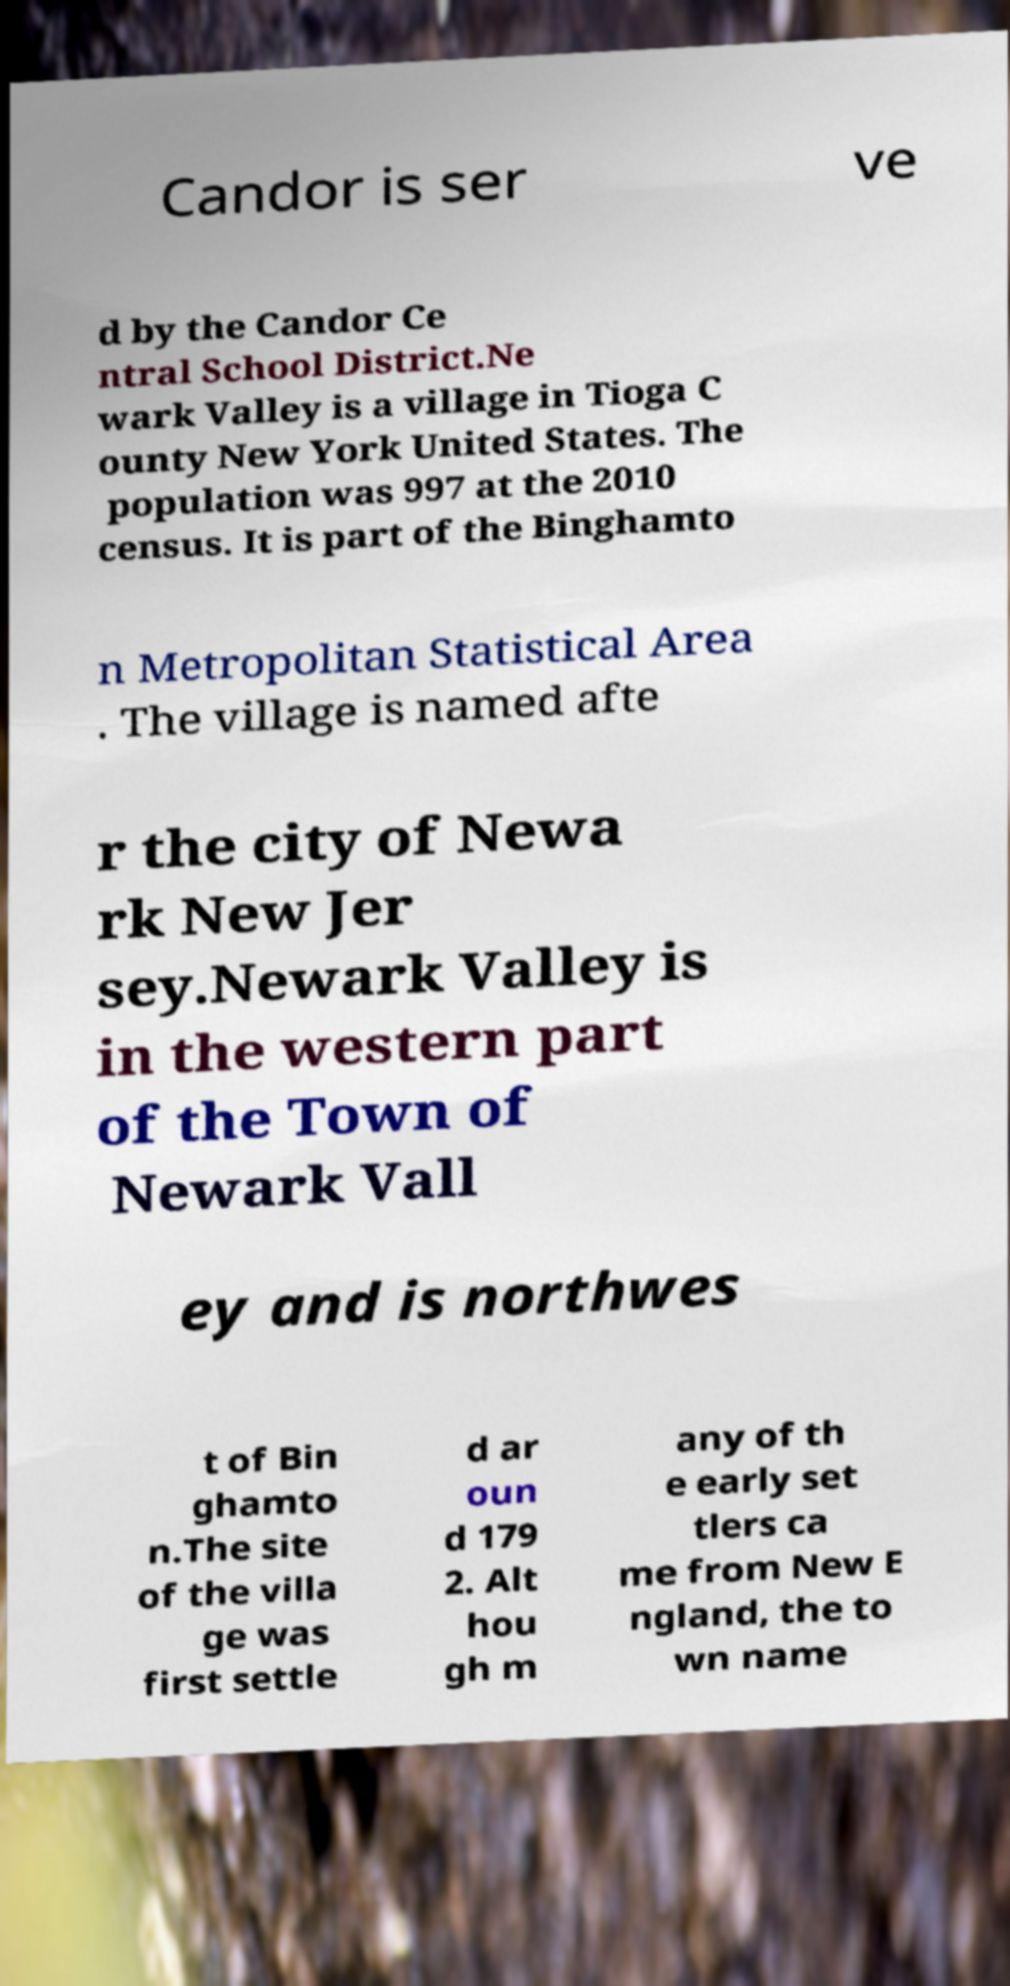There's text embedded in this image that I need extracted. Can you transcribe it verbatim? Candor is ser ve d by the Candor Ce ntral School District.Ne wark Valley is a village in Tioga C ounty New York United States. The population was 997 at the 2010 census. It is part of the Binghamto n Metropolitan Statistical Area . The village is named afte r the city of Newa rk New Jer sey.Newark Valley is in the western part of the Town of Newark Vall ey and is northwes t of Bin ghamto n.The site of the villa ge was first settle d ar oun d 179 2. Alt hou gh m any of th e early set tlers ca me from New E ngland, the to wn name 